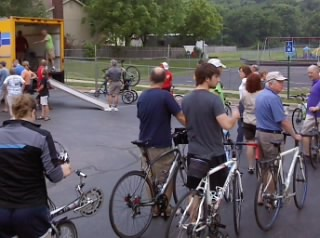Describe the objects in this image and their specific colors. I can see people in black, gray, navy, and maroon tones, people in black and gray tones, bicycle in black and gray tones, people in black and gray tones, and bicycle in black, gray, darkgray, and lightgray tones in this image. 